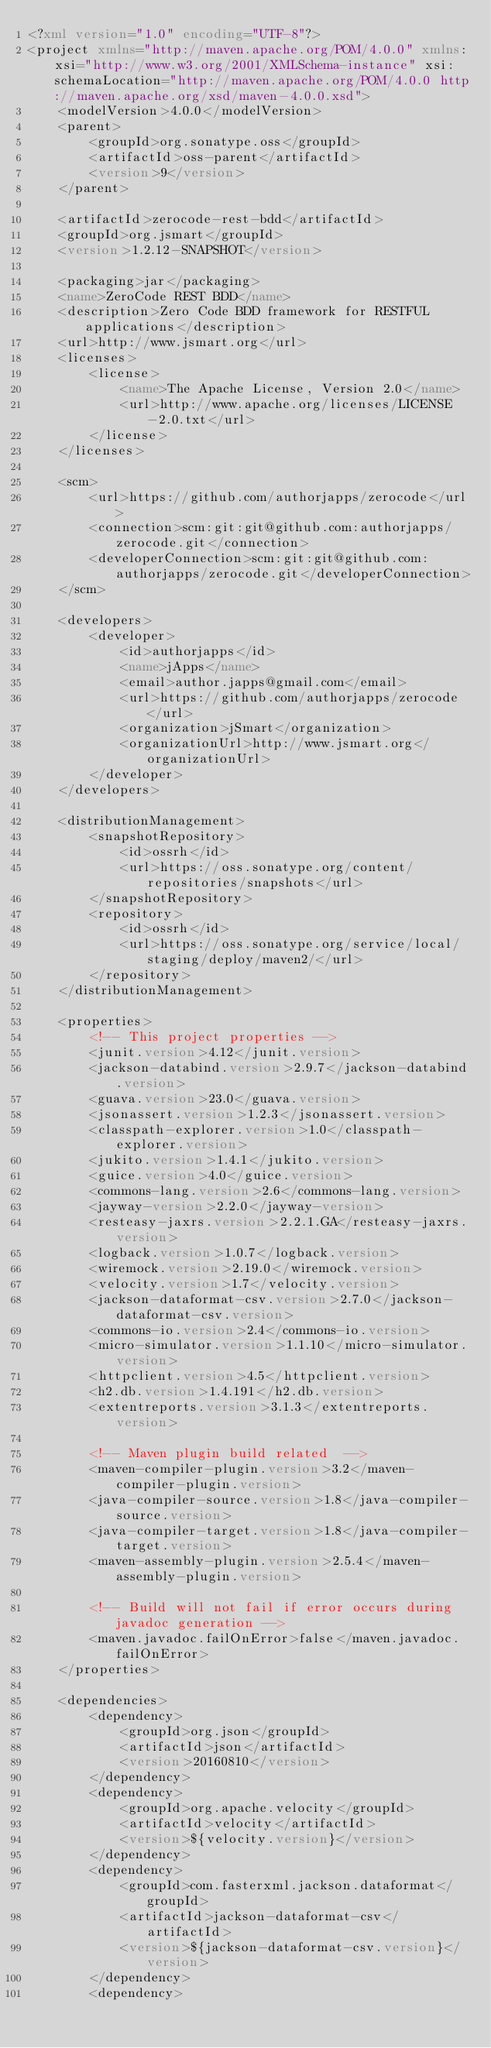<code> <loc_0><loc_0><loc_500><loc_500><_XML_><?xml version="1.0" encoding="UTF-8"?>
<project xmlns="http://maven.apache.org/POM/4.0.0" xmlns:xsi="http://www.w3.org/2001/XMLSchema-instance" xsi:schemaLocation="http://maven.apache.org/POM/4.0.0 http://maven.apache.org/xsd/maven-4.0.0.xsd">
    <modelVersion>4.0.0</modelVersion>
    <parent>
        <groupId>org.sonatype.oss</groupId>
        <artifactId>oss-parent</artifactId>
        <version>9</version>
    </parent>

    <artifactId>zerocode-rest-bdd</artifactId>
    <groupId>org.jsmart</groupId>
    <version>1.2.12-SNAPSHOT</version>

    <packaging>jar</packaging>
    <name>ZeroCode REST BDD</name>
    <description>Zero Code BDD framework for RESTFUL applications</description>
    <url>http://www.jsmart.org</url>
    <licenses>
        <license>
            <name>The Apache License, Version 2.0</name>
            <url>http://www.apache.org/licenses/LICENSE-2.0.txt</url>
        </license>
    </licenses>

    <scm>
        <url>https://github.com/authorjapps/zerocode</url>
        <connection>scm:git:git@github.com:authorjapps/zerocode.git</connection>
        <developerConnection>scm:git:git@github.com:authorjapps/zerocode.git</developerConnection>
    </scm>

    <developers>
        <developer>
            <id>authorjapps</id>
            <name>jApps</name>
            <email>author.japps@gmail.com</email>
            <url>https://github.com/authorjapps/zerocode</url>
            <organization>jSmart</organization>
            <organizationUrl>http://www.jsmart.org</organizationUrl>
        </developer>
    </developers>

    <distributionManagement>
        <snapshotRepository>
            <id>ossrh</id>
            <url>https://oss.sonatype.org/content/repositories/snapshots</url>
        </snapshotRepository>
        <repository>
            <id>ossrh</id>
            <url>https://oss.sonatype.org/service/local/staging/deploy/maven2/</url>
        </repository>
    </distributionManagement>

    <properties>
        <!-- This project properties -->
        <junit.version>4.12</junit.version>
        <jackson-databind.version>2.9.7</jackson-databind.version>
        <guava.version>23.0</guava.version>
        <jsonassert.version>1.2.3</jsonassert.version>
        <classpath-explorer.version>1.0</classpath-explorer.version>
        <jukito.version>1.4.1</jukito.version>
        <guice.version>4.0</guice.version>
        <commons-lang.version>2.6</commons-lang.version>
        <jayway-version>2.2.0</jayway-version>
        <resteasy-jaxrs.version>2.2.1.GA</resteasy-jaxrs.version>
        <logback.version>1.0.7</logback.version>
        <wiremock.version>2.19.0</wiremock.version>
        <velocity.version>1.7</velocity.version>
        <jackson-dataformat-csv.version>2.7.0</jackson-dataformat-csv.version>
        <commons-io.version>2.4</commons-io.version>
        <micro-simulator.version>1.1.10</micro-simulator.version>
        <httpclient.version>4.5</httpclient.version>
        <h2.db.version>1.4.191</h2.db.version>
        <extentreports.version>3.1.3</extentreports.version>

        <!-- Maven plugin build related  -->
        <maven-compiler-plugin.version>3.2</maven-compiler-plugin.version>
        <java-compiler-source.version>1.8</java-compiler-source.version>
        <java-compiler-target.version>1.8</java-compiler-target.version>
        <maven-assembly-plugin.version>2.5.4</maven-assembly-plugin.version>

        <!-- Build will not fail if error occurs during javadoc generation -->
        <maven.javadoc.failOnError>false</maven.javadoc.failOnError>
    </properties>

    <dependencies>
        <dependency>
            <groupId>org.json</groupId>
            <artifactId>json</artifactId>
            <version>20160810</version>
        </dependency>
        <dependency>
            <groupId>org.apache.velocity</groupId>
            <artifactId>velocity</artifactId>
            <version>${velocity.version}</version>
        </dependency>
        <dependency>
            <groupId>com.fasterxml.jackson.dataformat</groupId>
            <artifactId>jackson-dataformat-csv</artifactId>
            <version>${jackson-dataformat-csv.version}</version>
        </dependency>
        <dependency></code> 